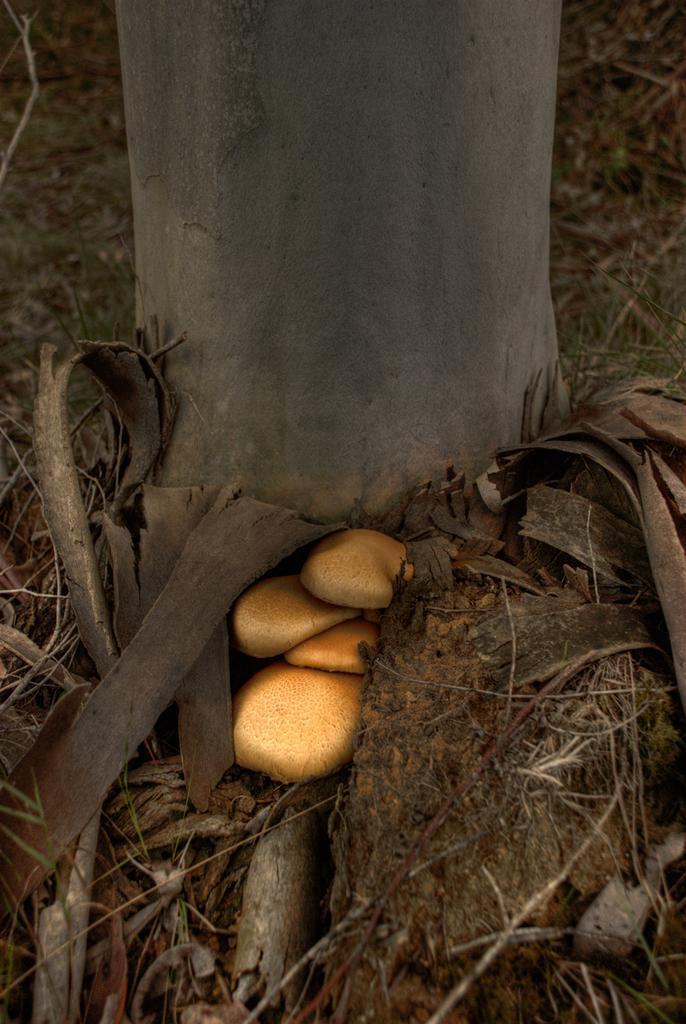Please provide a concise description of this image. In this image, we can see the trunk of the tree. We can also see some mushrooms. We can see the ground with some dried grass and pieces of wood. 